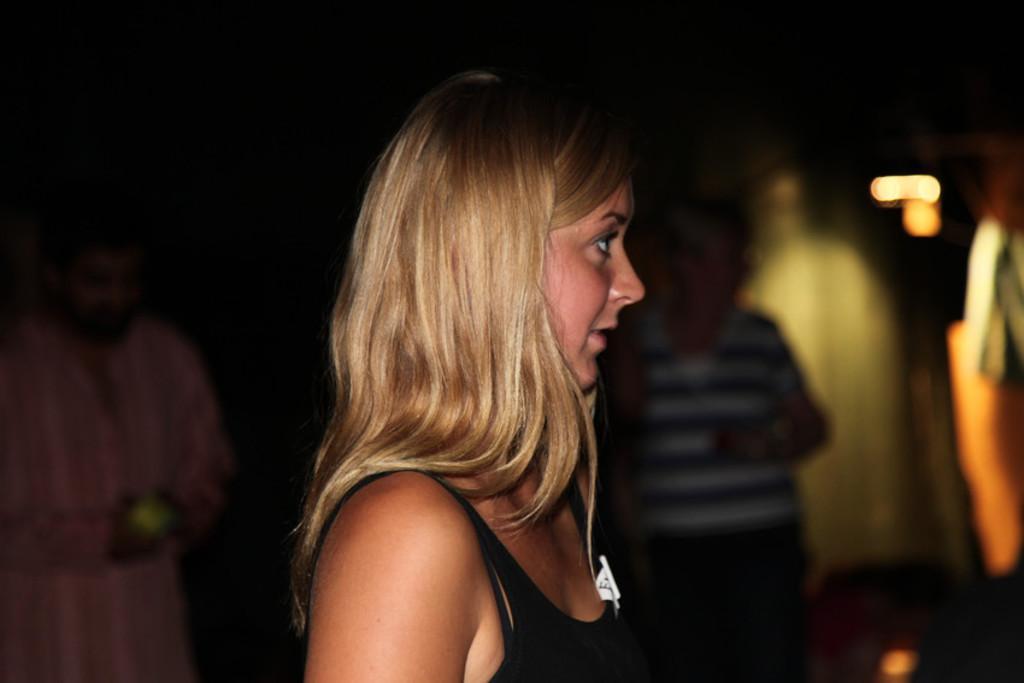Describe this image in one or two sentences. In this image there are persons truncated towards the bottom of the image, there is a person holding an object, there is a person truncated towards the left of the image, there are objects truncated towards the right of the image, the background of the image is dark and blurred. 